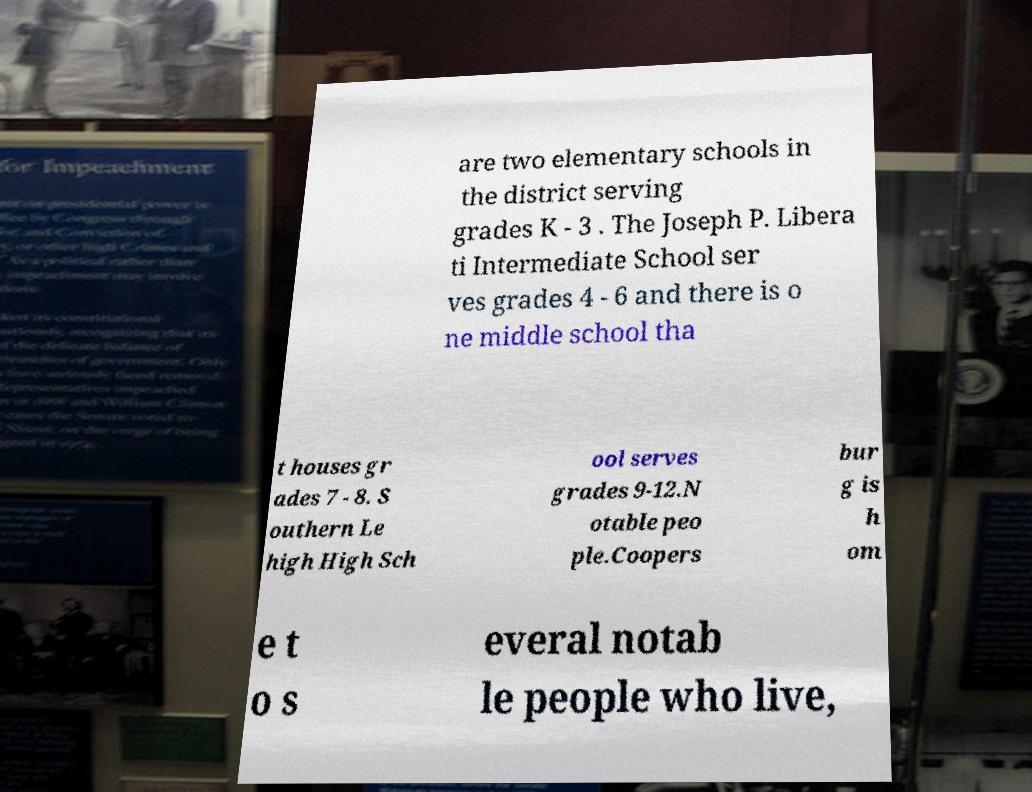I need the written content from this picture converted into text. Can you do that? are two elementary schools in the district serving grades K - 3 . The Joseph P. Libera ti Intermediate School ser ves grades 4 - 6 and there is o ne middle school tha t houses gr ades 7 - 8. S outhern Le high High Sch ool serves grades 9-12.N otable peo ple.Coopers bur g is h om e t o s everal notab le people who live, 